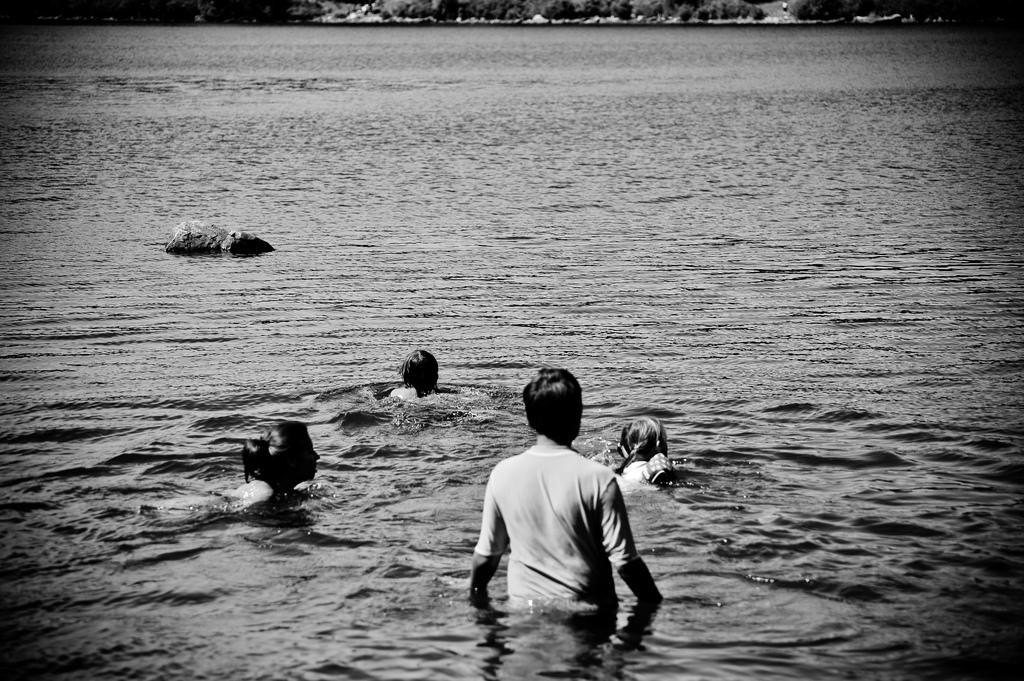What is the color scheme of the image? The image is black and white. What activity are the people in the image engaged in? The people in the image are swimming in the water. How many trees can be seen in the image? There are no trees visible in the image, as it features people swimming in the water. What type of butter is being used in the image? There is no butter present in the image. 